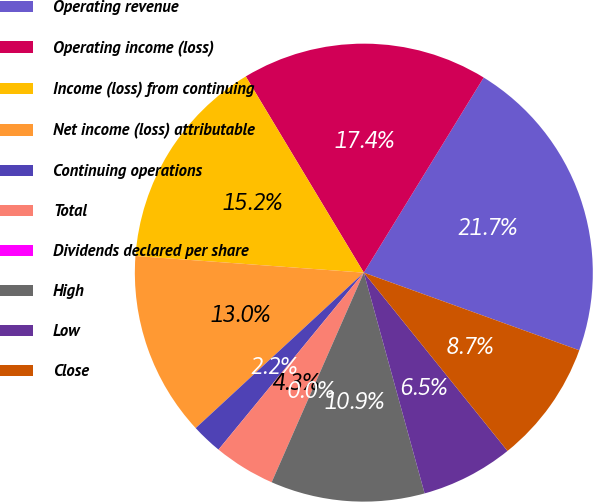Convert chart to OTSL. <chart><loc_0><loc_0><loc_500><loc_500><pie_chart><fcel>Operating revenue<fcel>Operating income (loss)<fcel>Income (loss) from continuing<fcel>Net income (loss) attributable<fcel>Continuing operations<fcel>Total<fcel>Dividends declared per share<fcel>High<fcel>Low<fcel>Close<nl><fcel>21.74%<fcel>17.39%<fcel>15.22%<fcel>13.04%<fcel>2.18%<fcel>4.35%<fcel>0.0%<fcel>10.87%<fcel>6.52%<fcel>8.7%<nl></chart> 